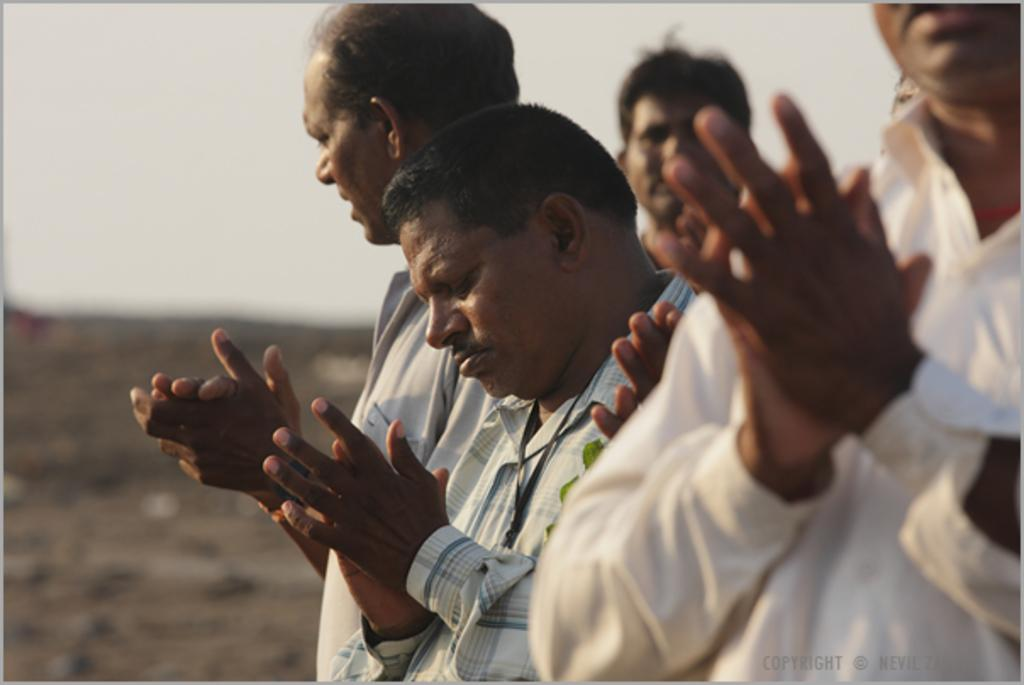Who or what is present in the image? There are people in the image. Can you describe the background of the image? The background of the image is blurred. What type of bee can be seen flying around the people in the image? There is no bee present in the image; the focus is on the people and the blurred background. 